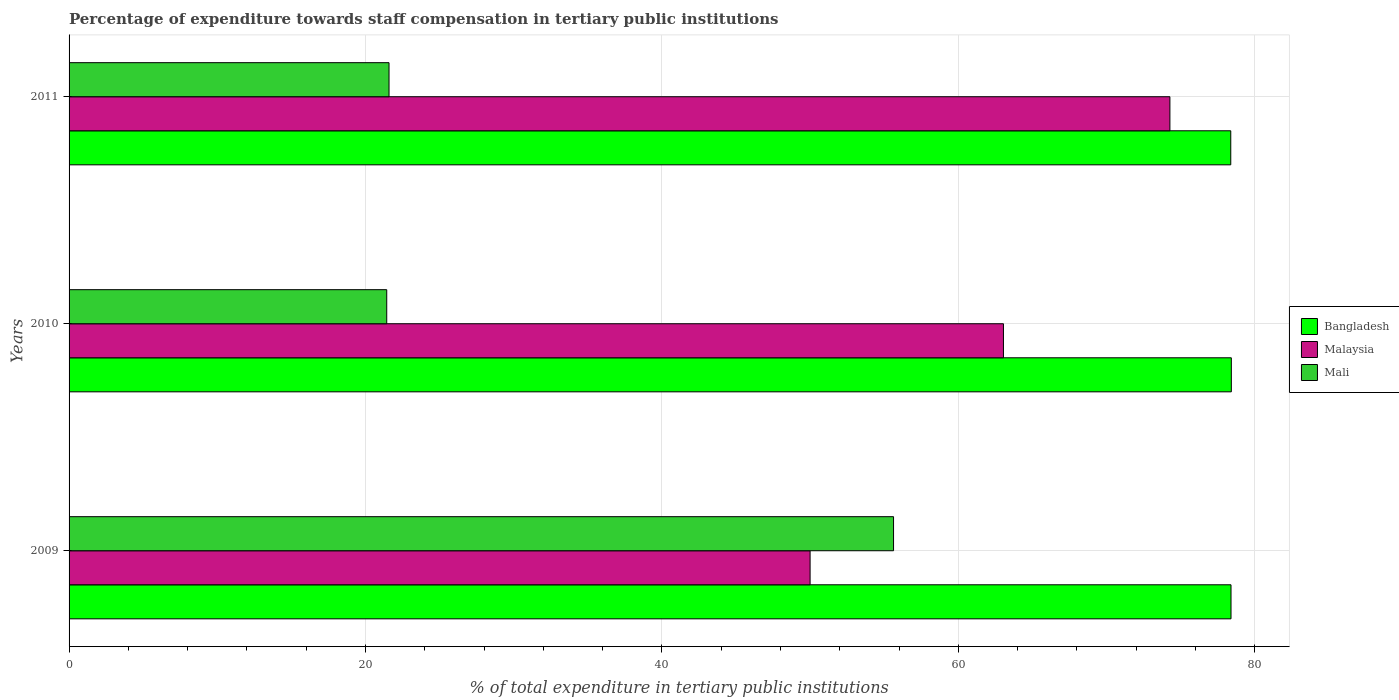Are the number of bars per tick equal to the number of legend labels?
Offer a terse response. Yes. How many bars are there on the 3rd tick from the bottom?
Your answer should be compact. 3. What is the label of the 3rd group of bars from the top?
Keep it short and to the point. 2009. What is the percentage of expenditure towards staff compensation in Malaysia in 2010?
Provide a short and direct response. 63.04. Across all years, what is the maximum percentage of expenditure towards staff compensation in Malaysia?
Your answer should be very brief. 74.27. Across all years, what is the minimum percentage of expenditure towards staff compensation in Mali?
Keep it short and to the point. 21.43. In which year was the percentage of expenditure towards staff compensation in Malaysia maximum?
Provide a succinct answer. 2011. In which year was the percentage of expenditure towards staff compensation in Mali minimum?
Your answer should be compact. 2010. What is the total percentage of expenditure towards staff compensation in Bangladesh in the graph?
Keep it short and to the point. 235.2. What is the difference between the percentage of expenditure towards staff compensation in Bangladesh in 2009 and that in 2010?
Ensure brevity in your answer.  -0.02. What is the difference between the percentage of expenditure towards staff compensation in Mali in 2010 and the percentage of expenditure towards staff compensation in Malaysia in 2009?
Offer a very short reply. -28.57. What is the average percentage of expenditure towards staff compensation in Mali per year?
Offer a terse response. 32.88. In the year 2009, what is the difference between the percentage of expenditure towards staff compensation in Bangladesh and percentage of expenditure towards staff compensation in Malaysia?
Provide a short and direct response. 28.4. In how many years, is the percentage of expenditure towards staff compensation in Bangladesh greater than 64 %?
Keep it short and to the point. 3. What is the ratio of the percentage of expenditure towards staff compensation in Bangladesh in 2009 to that in 2010?
Offer a very short reply. 1. Is the percentage of expenditure towards staff compensation in Mali in 2010 less than that in 2011?
Give a very brief answer. Yes. Is the difference between the percentage of expenditure towards staff compensation in Bangladesh in 2009 and 2010 greater than the difference between the percentage of expenditure towards staff compensation in Malaysia in 2009 and 2010?
Provide a short and direct response. Yes. What is the difference between the highest and the second highest percentage of expenditure towards staff compensation in Bangladesh?
Make the answer very short. 0.02. What is the difference between the highest and the lowest percentage of expenditure towards staff compensation in Bangladesh?
Provide a short and direct response. 0.04. What does the 2nd bar from the top in 2009 represents?
Provide a succinct answer. Malaysia. What does the 2nd bar from the bottom in 2010 represents?
Your response must be concise. Malaysia. Is it the case that in every year, the sum of the percentage of expenditure towards staff compensation in Mali and percentage of expenditure towards staff compensation in Malaysia is greater than the percentage of expenditure towards staff compensation in Bangladesh?
Make the answer very short. Yes. Are all the bars in the graph horizontal?
Ensure brevity in your answer.  Yes. How many years are there in the graph?
Provide a succinct answer. 3. What is the difference between two consecutive major ticks on the X-axis?
Provide a succinct answer. 20. Does the graph contain any zero values?
Provide a short and direct response. No. Where does the legend appear in the graph?
Offer a very short reply. Center right. What is the title of the graph?
Offer a terse response. Percentage of expenditure towards staff compensation in tertiary public institutions. Does "Comoros" appear as one of the legend labels in the graph?
Ensure brevity in your answer.  No. What is the label or title of the X-axis?
Offer a very short reply. % of total expenditure in tertiary public institutions. What is the label or title of the Y-axis?
Your answer should be compact. Years. What is the % of total expenditure in tertiary public institutions of Bangladesh in 2009?
Provide a short and direct response. 78.4. What is the % of total expenditure in tertiary public institutions of Malaysia in 2009?
Your response must be concise. 50. What is the % of total expenditure in tertiary public institutions of Mali in 2009?
Make the answer very short. 55.63. What is the % of total expenditure in tertiary public institutions in Bangladesh in 2010?
Provide a short and direct response. 78.42. What is the % of total expenditure in tertiary public institutions in Malaysia in 2010?
Keep it short and to the point. 63.04. What is the % of total expenditure in tertiary public institutions of Mali in 2010?
Offer a very short reply. 21.43. What is the % of total expenditure in tertiary public institutions of Bangladesh in 2011?
Your answer should be very brief. 78.38. What is the % of total expenditure in tertiary public institutions of Malaysia in 2011?
Keep it short and to the point. 74.27. What is the % of total expenditure in tertiary public institutions in Mali in 2011?
Offer a terse response. 21.59. Across all years, what is the maximum % of total expenditure in tertiary public institutions of Bangladesh?
Make the answer very short. 78.42. Across all years, what is the maximum % of total expenditure in tertiary public institutions of Malaysia?
Provide a short and direct response. 74.27. Across all years, what is the maximum % of total expenditure in tertiary public institutions of Mali?
Offer a very short reply. 55.63. Across all years, what is the minimum % of total expenditure in tertiary public institutions in Bangladesh?
Give a very brief answer. 78.38. Across all years, what is the minimum % of total expenditure in tertiary public institutions in Malaysia?
Give a very brief answer. 50. Across all years, what is the minimum % of total expenditure in tertiary public institutions of Mali?
Ensure brevity in your answer.  21.43. What is the total % of total expenditure in tertiary public institutions of Bangladesh in the graph?
Offer a very short reply. 235.2. What is the total % of total expenditure in tertiary public institutions of Malaysia in the graph?
Your answer should be compact. 187.31. What is the total % of total expenditure in tertiary public institutions in Mali in the graph?
Your answer should be very brief. 98.65. What is the difference between the % of total expenditure in tertiary public institutions in Bangladesh in 2009 and that in 2010?
Keep it short and to the point. -0.02. What is the difference between the % of total expenditure in tertiary public institutions of Malaysia in 2009 and that in 2010?
Provide a short and direct response. -13.05. What is the difference between the % of total expenditure in tertiary public institutions of Mali in 2009 and that in 2010?
Provide a succinct answer. 34.2. What is the difference between the % of total expenditure in tertiary public institutions in Bangladesh in 2009 and that in 2011?
Your response must be concise. 0.02. What is the difference between the % of total expenditure in tertiary public institutions of Malaysia in 2009 and that in 2011?
Make the answer very short. -24.28. What is the difference between the % of total expenditure in tertiary public institutions in Mali in 2009 and that in 2011?
Offer a terse response. 34.04. What is the difference between the % of total expenditure in tertiary public institutions of Bangladesh in 2010 and that in 2011?
Provide a short and direct response. 0.04. What is the difference between the % of total expenditure in tertiary public institutions in Malaysia in 2010 and that in 2011?
Your answer should be very brief. -11.23. What is the difference between the % of total expenditure in tertiary public institutions of Mali in 2010 and that in 2011?
Your response must be concise. -0.16. What is the difference between the % of total expenditure in tertiary public institutions in Bangladesh in 2009 and the % of total expenditure in tertiary public institutions in Malaysia in 2010?
Keep it short and to the point. 15.35. What is the difference between the % of total expenditure in tertiary public institutions in Bangladesh in 2009 and the % of total expenditure in tertiary public institutions in Mali in 2010?
Give a very brief answer. 56.96. What is the difference between the % of total expenditure in tertiary public institutions of Malaysia in 2009 and the % of total expenditure in tertiary public institutions of Mali in 2010?
Offer a very short reply. 28.57. What is the difference between the % of total expenditure in tertiary public institutions in Bangladesh in 2009 and the % of total expenditure in tertiary public institutions in Malaysia in 2011?
Provide a short and direct response. 4.12. What is the difference between the % of total expenditure in tertiary public institutions of Bangladesh in 2009 and the % of total expenditure in tertiary public institutions of Mali in 2011?
Your answer should be compact. 56.81. What is the difference between the % of total expenditure in tertiary public institutions of Malaysia in 2009 and the % of total expenditure in tertiary public institutions of Mali in 2011?
Offer a terse response. 28.41. What is the difference between the % of total expenditure in tertiary public institutions of Bangladesh in 2010 and the % of total expenditure in tertiary public institutions of Malaysia in 2011?
Give a very brief answer. 4.14. What is the difference between the % of total expenditure in tertiary public institutions in Bangladesh in 2010 and the % of total expenditure in tertiary public institutions in Mali in 2011?
Your answer should be compact. 56.83. What is the difference between the % of total expenditure in tertiary public institutions in Malaysia in 2010 and the % of total expenditure in tertiary public institutions in Mali in 2011?
Offer a very short reply. 41.46. What is the average % of total expenditure in tertiary public institutions in Bangladesh per year?
Make the answer very short. 78.4. What is the average % of total expenditure in tertiary public institutions of Malaysia per year?
Provide a short and direct response. 62.44. What is the average % of total expenditure in tertiary public institutions of Mali per year?
Your answer should be very brief. 32.88. In the year 2009, what is the difference between the % of total expenditure in tertiary public institutions in Bangladesh and % of total expenditure in tertiary public institutions in Malaysia?
Your answer should be compact. 28.4. In the year 2009, what is the difference between the % of total expenditure in tertiary public institutions in Bangladesh and % of total expenditure in tertiary public institutions in Mali?
Ensure brevity in your answer.  22.77. In the year 2009, what is the difference between the % of total expenditure in tertiary public institutions in Malaysia and % of total expenditure in tertiary public institutions in Mali?
Offer a terse response. -5.63. In the year 2010, what is the difference between the % of total expenditure in tertiary public institutions in Bangladesh and % of total expenditure in tertiary public institutions in Malaysia?
Provide a succinct answer. 15.38. In the year 2010, what is the difference between the % of total expenditure in tertiary public institutions in Bangladesh and % of total expenditure in tertiary public institutions in Mali?
Keep it short and to the point. 56.99. In the year 2010, what is the difference between the % of total expenditure in tertiary public institutions in Malaysia and % of total expenditure in tertiary public institutions in Mali?
Keep it short and to the point. 41.61. In the year 2011, what is the difference between the % of total expenditure in tertiary public institutions of Bangladesh and % of total expenditure in tertiary public institutions of Malaysia?
Your answer should be very brief. 4.11. In the year 2011, what is the difference between the % of total expenditure in tertiary public institutions in Bangladesh and % of total expenditure in tertiary public institutions in Mali?
Offer a terse response. 56.79. In the year 2011, what is the difference between the % of total expenditure in tertiary public institutions of Malaysia and % of total expenditure in tertiary public institutions of Mali?
Provide a short and direct response. 52.69. What is the ratio of the % of total expenditure in tertiary public institutions in Malaysia in 2009 to that in 2010?
Offer a terse response. 0.79. What is the ratio of the % of total expenditure in tertiary public institutions of Mali in 2009 to that in 2010?
Your response must be concise. 2.6. What is the ratio of the % of total expenditure in tertiary public institutions of Malaysia in 2009 to that in 2011?
Keep it short and to the point. 0.67. What is the ratio of the % of total expenditure in tertiary public institutions of Mali in 2009 to that in 2011?
Your response must be concise. 2.58. What is the ratio of the % of total expenditure in tertiary public institutions of Malaysia in 2010 to that in 2011?
Keep it short and to the point. 0.85. What is the difference between the highest and the second highest % of total expenditure in tertiary public institutions of Bangladesh?
Ensure brevity in your answer.  0.02. What is the difference between the highest and the second highest % of total expenditure in tertiary public institutions of Malaysia?
Offer a terse response. 11.23. What is the difference between the highest and the second highest % of total expenditure in tertiary public institutions of Mali?
Provide a succinct answer. 34.04. What is the difference between the highest and the lowest % of total expenditure in tertiary public institutions in Bangladesh?
Keep it short and to the point. 0.04. What is the difference between the highest and the lowest % of total expenditure in tertiary public institutions in Malaysia?
Your answer should be very brief. 24.28. What is the difference between the highest and the lowest % of total expenditure in tertiary public institutions in Mali?
Your answer should be very brief. 34.2. 